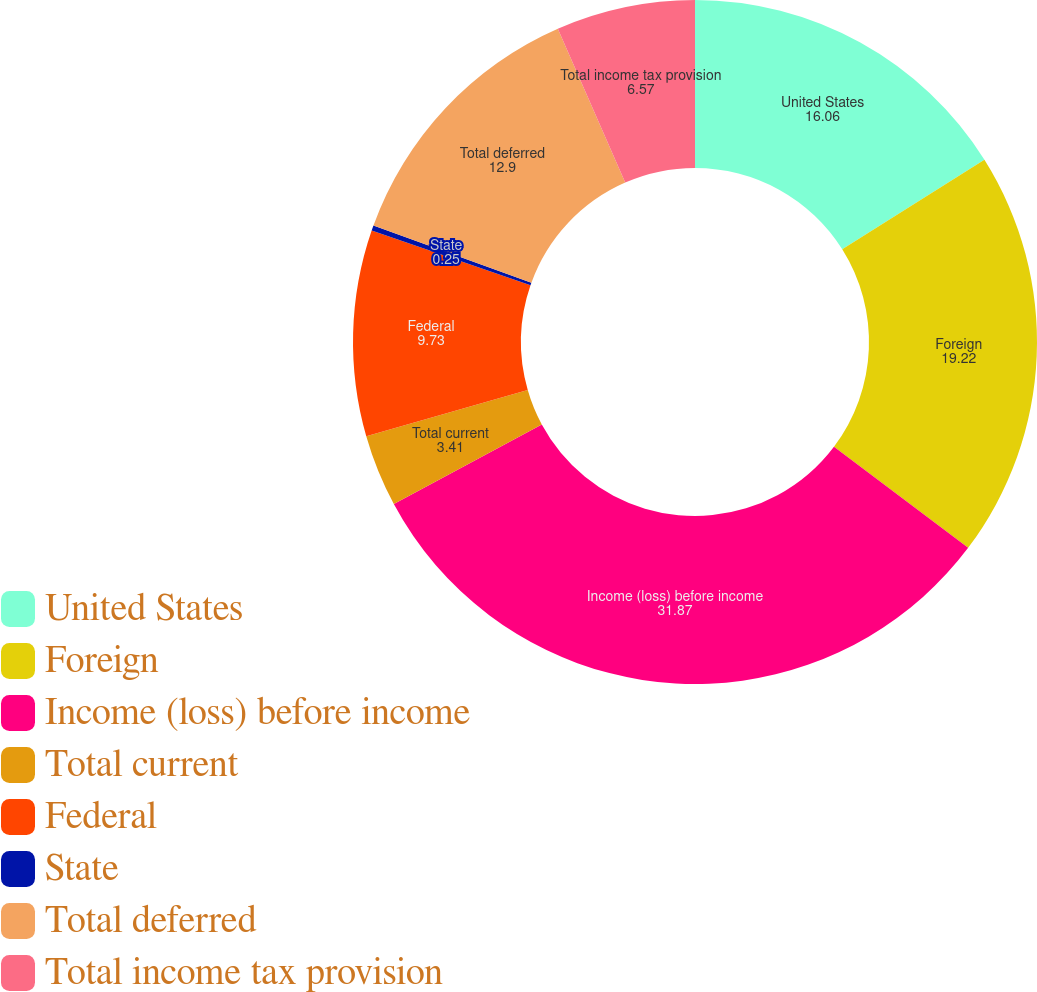Convert chart. <chart><loc_0><loc_0><loc_500><loc_500><pie_chart><fcel>United States<fcel>Foreign<fcel>Income (loss) before income<fcel>Total current<fcel>Federal<fcel>State<fcel>Total deferred<fcel>Total income tax provision<nl><fcel>16.06%<fcel>19.22%<fcel>31.87%<fcel>3.41%<fcel>9.73%<fcel>0.25%<fcel>12.9%<fcel>6.57%<nl></chart> 